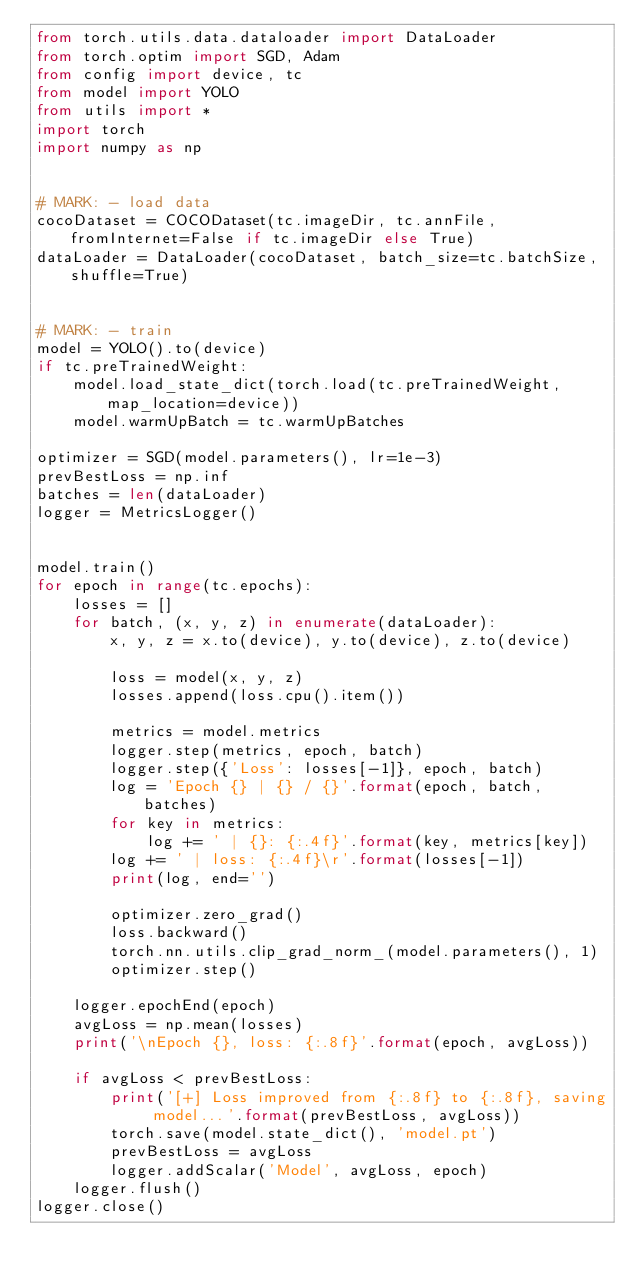Convert code to text. <code><loc_0><loc_0><loc_500><loc_500><_Python_>from torch.utils.data.dataloader import DataLoader
from torch.optim import SGD, Adam
from config import device, tc
from model import YOLO
from utils import *
import torch
import numpy as np


# MARK: - load data
cocoDataset = COCODataset(tc.imageDir, tc.annFile, fromInternet=False if tc.imageDir else True)
dataLoader = DataLoader(cocoDataset, batch_size=tc.batchSize, shuffle=True)


# MARK: - train
model = YOLO().to(device)
if tc.preTrainedWeight:
    model.load_state_dict(torch.load(tc.preTrainedWeight, map_location=device))
    model.warmUpBatch = tc.warmUpBatches

optimizer = SGD(model.parameters(), lr=1e-3)
prevBestLoss = np.inf
batches = len(dataLoader)
logger = MetricsLogger()


model.train()
for epoch in range(tc.epochs):
    losses = []
    for batch, (x, y, z) in enumerate(dataLoader):
        x, y, z = x.to(device), y.to(device), z.to(device)

        loss = model(x, y, z)
        losses.append(loss.cpu().item())

        metrics = model.metrics
        logger.step(metrics, epoch, batch)
        logger.step({'Loss': losses[-1]}, epoch, batch)
        log = 'Epoch {} | {} / {}'.format(epoch, batch, batches)
        for key in metrics:
            log += ' | {}: {:.4f}'.format(key, metrics[key])
        log += ' | loss: {:.4f}\r'.format(losses[-1])
        print(log, end='')

        optimizer.zero_grad()
        loss.backward()
        torch.nn.utils.clip_grad_norm_(model.parameters(), 1)
        optimizer.step()

    logger.epochEnd(epoch)
    avgLoss = np.mean(losses)
    print('\nEpoch {}, loss: {:.8f}'.format(epoch, avgLoss))

    if avgLoss < prevBestLoss:
        print('[+] Loss improved from {:.8f} to {:.8f}, saving model...'.format(prevBestLoss, avgLoss))
        torch.save(model.state_dict(), 'model.pt')
        prevBestLoss = avgLoss
        logger.addScalar('Model', avgLoss, epoch)
    logger.flush()
logger.close()
</code> 